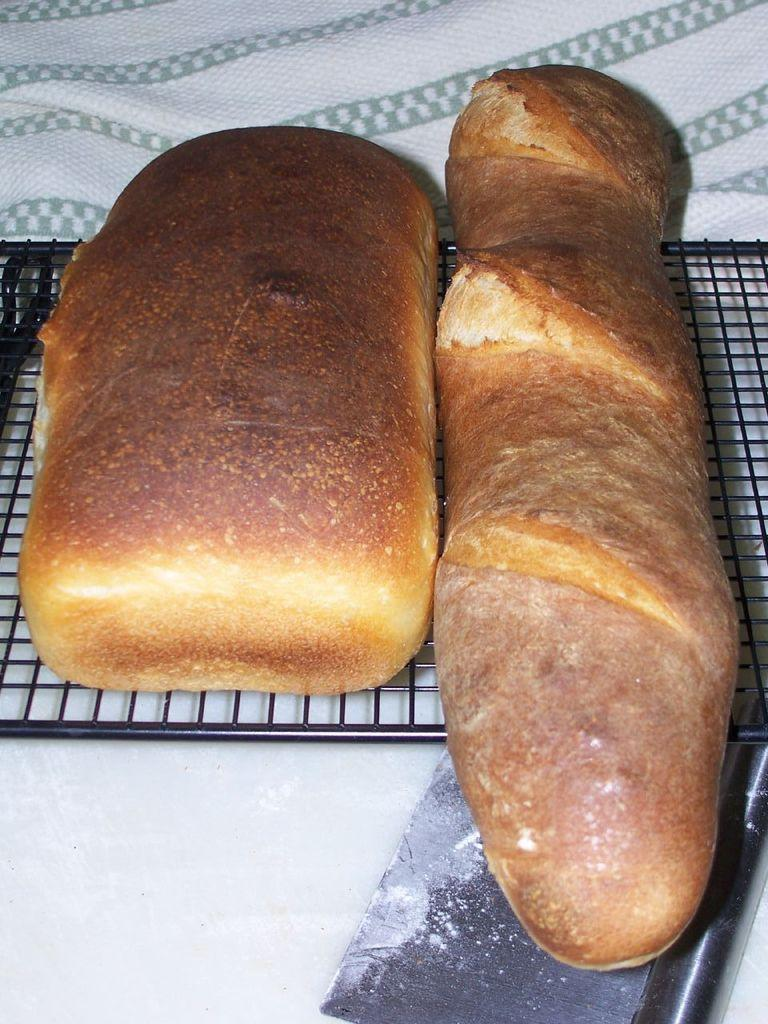What is being cooked on the grill in the image? There is bread on the grill in the image. Where is the grill located? The grill is placed on a table. What is covering the table in the image? The table has a cloth on it. Can you describe the object on the table? Unfortunately, the facts provided do not give enough information to describe the object on the table. What type of country is depicted in the image? There is no country depicted in the image; it features a grill with bread on it, a table with a cloth, and an unspecified object. How many wings are visible in the image? There are no wings present in the image. 